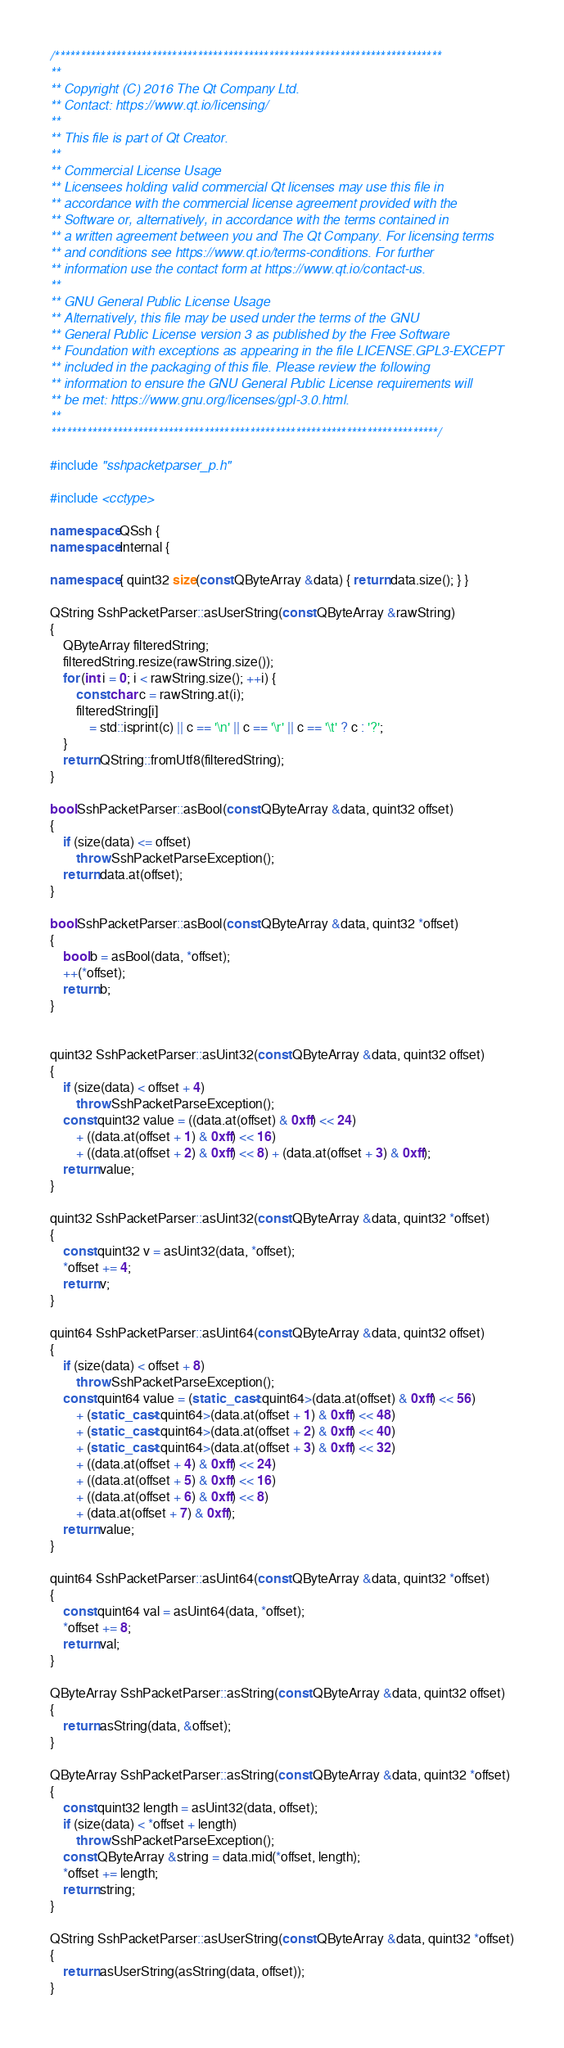<code> <loc_0><loc_0><loc_500><loc_500><_C++_>/****************************************************************************
**
** Copyright (C) 2016 The Qt Company Ltd.
** Contact: https://www.qt.io/licensing/
**
** This file is part of Qt Creator.
**
** Commercial License Usage
** Licensees holding valid commercial Qt licenses may use this file in
** accordance with the commercial license agreement provided with the
** Software or, alternatively, in accordance with the terms contained in
** a written agreement between you and The Qt Company. For licensing terms
** and conditions see https://www.qt.io/terms-conditions. For further
** information use the contact form at https://www.qt.io/contact-us.
**
** GNU General Public License Usage
** Alternatively, this file may be used under the terms of the GNU
** General Public License version 3 as published by the Free Software
** Foundation with exceptions as appearing in the file LICENSE.GPL3-EXCEPT
** included in the packaging of this file. Please review the following
** information to ensure the GNU General Public License requirements will
** be met: https://www.gnu.org/licenses/gpl-3.0.html.
**
****************************************************************************/

#include "sshpacketparser_p.h"

#include <cctype>

namespace QSsh {
namespace Internal {

namespace { quint32 size(const QByteArray &data) { return data.size(); } }

QString SshPacketParser::asUserString(const QByteArray &rawString)
{
    QByteArray filteredString;
    filteredString.resize(rawString.size());
    for (int i = 0; i < rawString.size(); ++i) {
        const char c = rawString.at(i);
        filteredString[i]
            = std::isprint(c) || c == '\n' || c == '\r' || c == '\t' ? c : '?';
    }
    return QString::fromUtf8(filteredString);
}

bool SshPacketParser::asBool(const QByteArray &data, quint32 offset)
{
    if (size(data) <= offset)
        throw SshPacketParseException();
    return data.at(offset);
}

bool SshPacketParser::asBool(const QByteArray &data, quint32 *offset)
{
    bool b = asBool(data, *offset);
    ++(*offset);
    return b;
}


quint32 SshPacketParser::asUint32(const QByteArray &data, quint32 offset)
{
    if (size(data) < offset + 4)
        throw SshPacketParseException();
    const quint32 value = ((data.at(offset) & 0xff) << 24)
        + ((data.at(offset + 1) & 0xff) << 16)
        + ((data.at(offset + 2) & 0xff) << 8) + (data.at(offset + 3) & 0xff);
    return value;
}

quint32 SshPacketParser::asUint32(const QByteArray &data, quint32 *offset)
{
    const quint32 v = asUint32(data, *offset);
    *offset += 4;
    return v;
}

quint64 SshPacketParser::asUint64(const QByteArray &data, quint32 offset)
{
    if (size(data) < offset + 8)
        throw SshPacketParseException();
    const quint64 value = (static_cast<quint64>(data.at(offset) & 0xff) << 56)
        + (static_cast<quint64>(data.at(offset + 1) & 0xff) << 48)
        + (static_cast<quint64>(data.at(offset + 2) & 0xff) << 40)
        + (static_cast<quint64>(data.at(offset + 3) & 0xff) << 32)
        + ((data.at(offset + 4) & 0xff) << 24)
        + ((data.at(offset + 5) & 0xff) << 16)
        + ((data.at(offset + 6) & 0xff) << 8)
        + (data.at(offset + 7) & 0xff);
    return value;
}

quint64 SshPacketParser::asUint64(const QByteArray &data, quint32 *offset)
{
    const quint64 val = asUint64(data, *offset);
    *offset += 8;
    return val;
}

QByteArray SshPacketParser::asString(const QByteArray &data, quint32 offset)
{
    return asString(data, &offset);
}

QByteArray SshPacketParser::asString(const QByteArray &data, quint32 *offset)
{
    const quint32 length = asUint32(data, offset);
    if (size(data) < *offset + length)
        throw SshPacketParseException();
    const QByteArray &string = data.mid(*offset, length);
    *offset += length;
    return string;
}

QString SshPacketParser::asUserString(const QByteArray &data, quint32 *offset)
{
    return asUserString(asString(data, offset));
}
</code> 